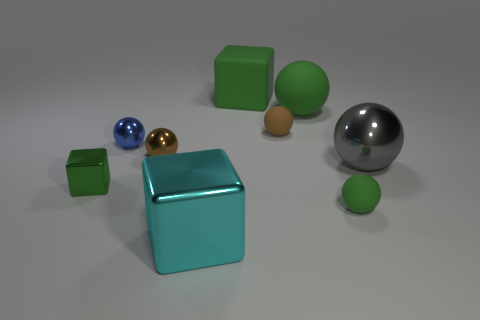How many green spheres must be subtracted to get 1 green spheres? 1 Subtract all blue balls. How many green cubes are left? 2 Subtract all brown shiny spheres. How many spheres are left? 5 Subtract all brown balls. How many balls are left? 4 Subtract 1 blocks. How many blocks are left? 2 Add 1 tiny brown matte things. How many objects exist? 10 Subtract all spheres. How many objects are left? 3 Subtract all yellow cubes. Subtract all brown spheres. How many cubes are left? 3 Add 4 red matte blocks. How many red matte blocks exist? 4 Subtract 0 gray cylinders. How many objects are left? 9 